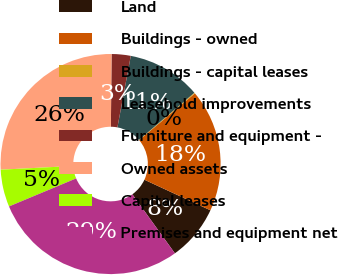<chart> <loc_0><loc_0><loc_500><loc_500><pie_chart><fcel>Land<fcel>Buildings - owned<fcel>Buildings - capital leases<fcel>Leasehold improvements<fcel>Furniture and equipment -<fcel>Owned assets<fcel>Capital leases<fcel>Premises and equipment net<nl><fcel>8.16%<fcel>18.0%<fcel>0.12%<fcel>10.84%<fcel>2.8%<fcel>25.96%<fcel>5.48%<fcel>28.64%<nl></chart> 